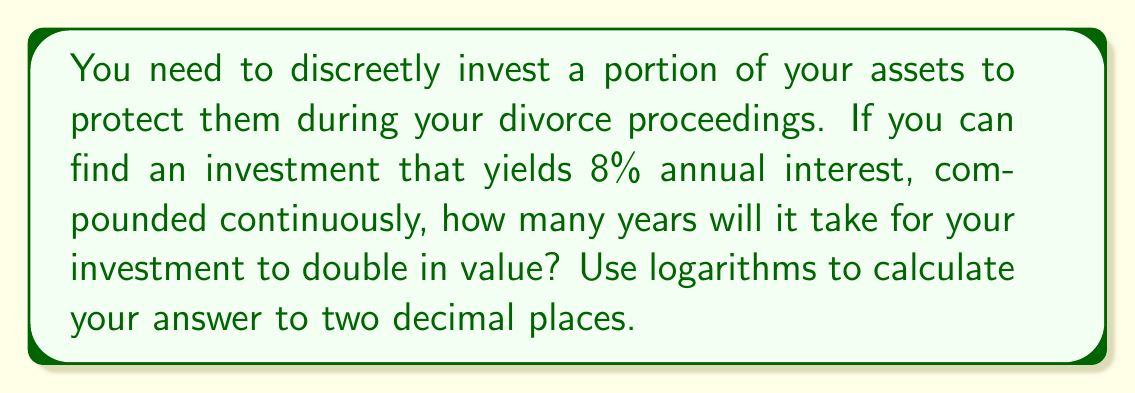Solve this math problem. To solve this problem, we'll use the continuous compound interest formula and the properties of logarithms:

1) The formula for continuous compound interest is:
   $A = P e^{rt}$
   Where A is the final amount, P is the principal (initial investment), r is the interest rate, and t is the time in years.

2) We want to find t when the amount has doubled, so:
   $2P = P e^{rt}$

3) Divide both sides by P:
   $2 = e^{rt}$

4) Take the natural logarithm of both sides:
   $\ln(2) = \ln(e^{rt})$

5) Using the logarithm property $\ln(e^x) = x$:
   $\ln(2) = rt$

6) Solve for t:
   $t = \frac{\ln(2)}{r}$

7) Substitute r = 0.08 (8% as a decimal):
   $t = \frac{\ln(2)}{0.08}$

8) Calculate:
   $t \approx 8.6643$

9) Rounding to two decimal places:
   $t \approx 8.66$ years
Answer: 8.66 years 